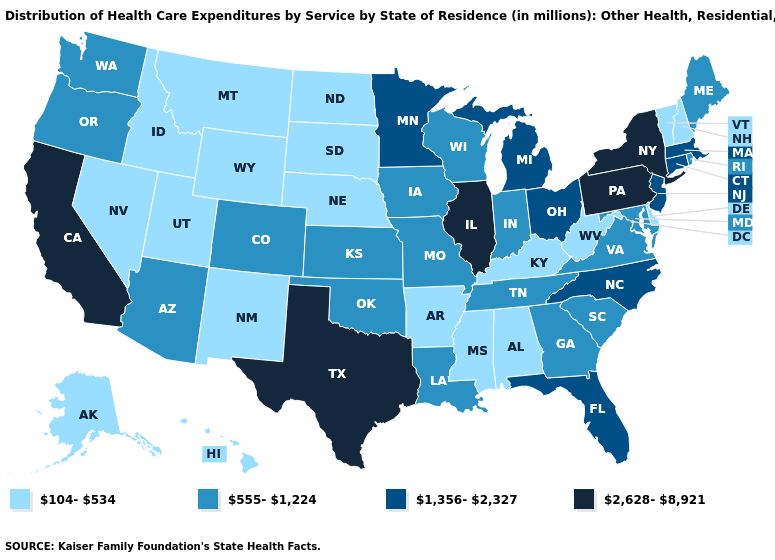What is the value of Wyoming?
Concise answer only. 104-534. Which states have the highest value in the USA?
Answer briefly. California, Illinois, New York, Pennsylvania, Texas. Does the map have missing data?
Answer briefly. No. What is the value of Wyoming?
Answer briefly. 104-534. Among the states that border Alabama , does Georgia have the lowest value?
Short answer required. No. Does the first symbol in the legend represent the smallest category?
Be succinct. Yes. Which states have the lowest value in the USA?
Be succinct. Alabama, Alaska, Arkansas, Delaware, Hawaii, Idaho, Kentucky, Mississippi, Montana, Nebraska, Nevada, New Hampshire, New Mexico, North Dakota, South Dakota, Utah, Vermont, West Virginia, Wyoming. Name the states that have a value in the range 1,356-2,327?
Short answer required. Connecticut, Florida, Massachusetts, Michigan, Minnesota, New Jersey, North Carolina, Ohio. Does Alabama have the same value as Colorado?
Answer briefly. No. Among the states that border California , which have the highest value?
Quick response, please. Arizona, Oregon. Name the states that have a value in the range 104-534?
Concise answer only. Alabama, Alaska, Arkansas, Delaware, Hawaii, Idaho, Kentucky, Mississippi, Montana, Nebraska, Nevada, New Hampshire, New Mexico, North Dakota, South Dakota, Utah, Vermont, West Virginia, Wyoming. Does Missouri have the same value as Ohio?
Short answer required. No. Name the states that have a value in the range 1,356-2,327?
Concise answer only. Connecticut, Florida, Massachusetts, Michigan, Minnesota, New Jersey, North Carolina, Ohio. Does the first symbol in the legend represent the smallest category?
Answer briefly. Yes. 